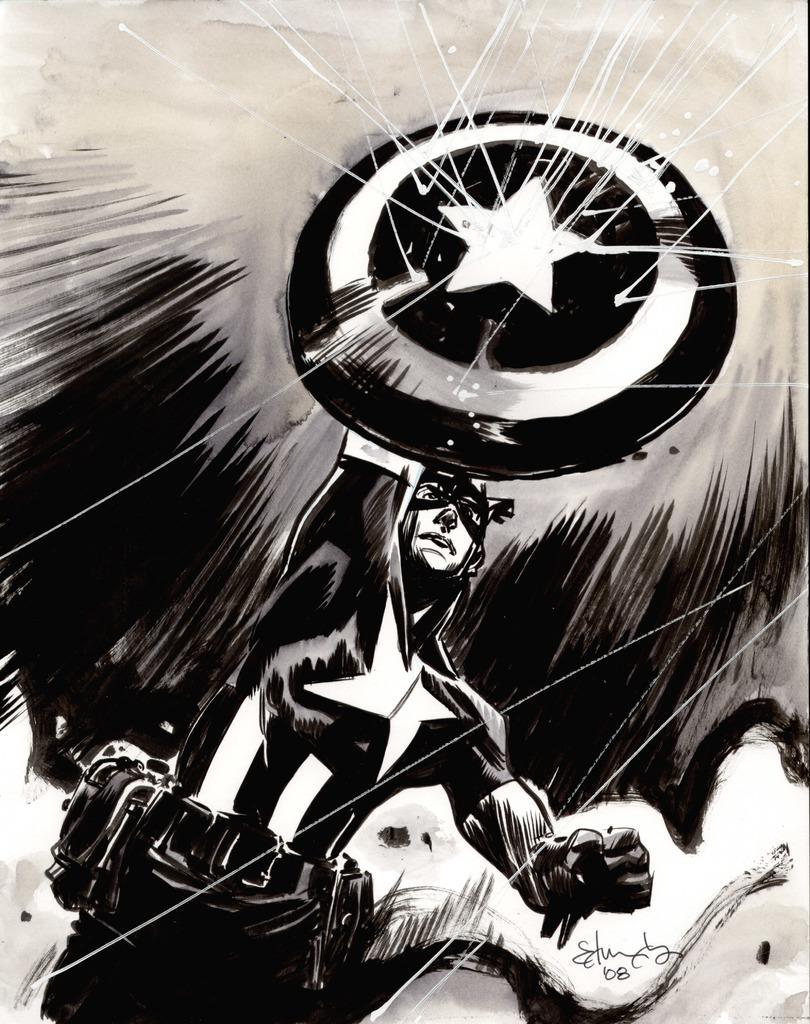In one or two sentences, can you explain what this image depicts? In the foreground of this cartoon image, there is a man wearing gloves and mask is holding a shield and also it seems like there are rays hitting the shield. 